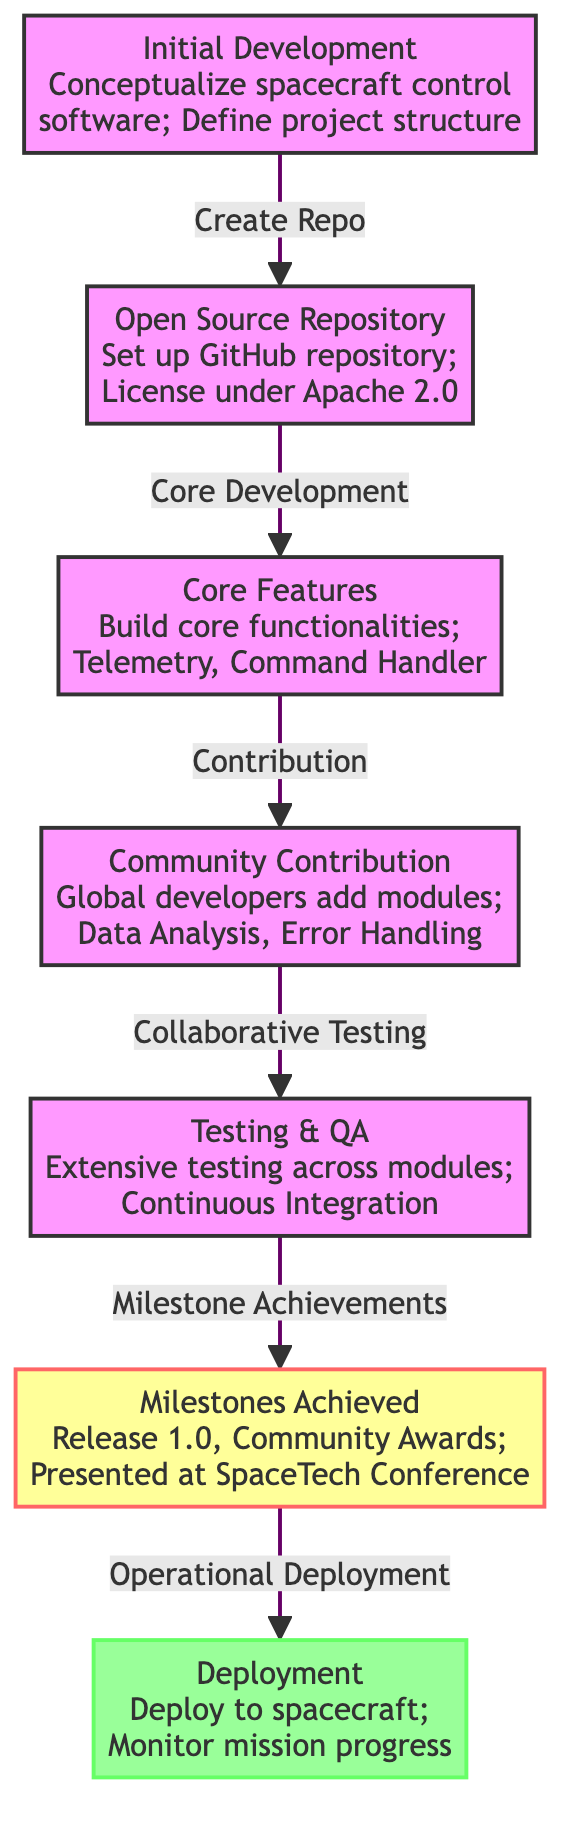What is the first step in the journey of the spacecraft mission control software? The first step is "Initial Development," which includes conceptualizing the spacecraft control software and defining the project structure.
Answer: Initial Development How many major milestones are listed in the diagram? There is one major milestone mentioned in the diagram, which is "Milestones Achieved."
Answer: One What license is used for the open-source repository? The repository is licensed under "Apache 2.0."
Answer: Apache 2.0 What activity follows after "Community Contribution"? The activity that follows is "Testing & QA," which involves extensive testing across modules and implementing continuous integration.
Answer: Testing & QA Which task is marked with the milestone class in the diagram? "Milestones Achieved" is marked with the milestone class, indicating significant achievements in the project.
Answer: Milestones Achieved What is the last step in the process outlined in the diagram? The last step is "Deployment," which involves deploying the software to the spacecraft and monitoring mission progress.
Answer: Deployment How does the community contribute to the project according to the diagram? The community contributes by adding modules such as data analysis and error handling to the mission control software.
Answer: Adding modules Which two steps are directly connected by the "Collaborative Testing" relationship? "Community Contribution" is directly connected to "Testing & QA" by the "Collaborative Testing" relationship.
Answer: Community Contribution and Testing & QA What action leads to the "Milestone Achievements"? The action that leads to "Milestone Achievements" is "Testing & QA," where extensive testing shows the readiness of the software.
Answer: Testing & QA 